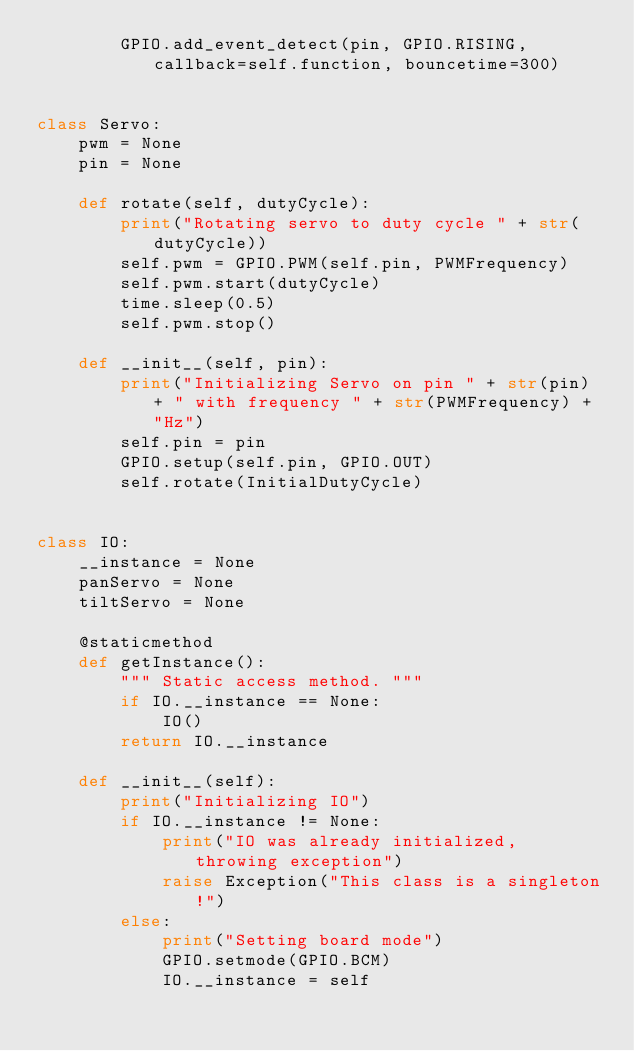<code> <loc_0><loc_0><loc_500><loc_500><_Python_>		GPIO.add_event_detect(pin, GPIO.RISING, callback=self.function, bouncetime=300)


class Servo:
	pwm = None
	pin = None

	def rotate(self, dutyCycle):
		print("Rotating servo to duty cycle " + str(dutyCycle))
		self.pwm = GPIO.PWM(self.pin, PWMFrequency)
		self.pwm.start(dutyCycle)
		time.sleep(0.5)
		self.pwm.stop()

	def __init__(self, pin):
		print("Initializing Servo on pin " + str(pin) + " with frequency " + str(PWMFrequency) + "Hz")
		self.pin = pin
		GPIO.setup(self.pin, GPIO.OUT)
		self.rotate(InitialDutyCycle)


class IO:
	__instance = None
	panServo = None
	tiltServo = None

	@staticmethod
	def getInstance():
		""" Static access method. """
		if IO.__instance == None:
			IO()
		return IO.__instance

	def __init__(self):
		print("Initializing IO")
		if IO.__instance != None:
			print("IO was already initialized, throwing exception")
			raise Exception("This class is a singleton!")
		else:
			print("Setting board mode")
			GPIO.setmode(GPIO.BCM)
			IO.__instance = self
</code> 